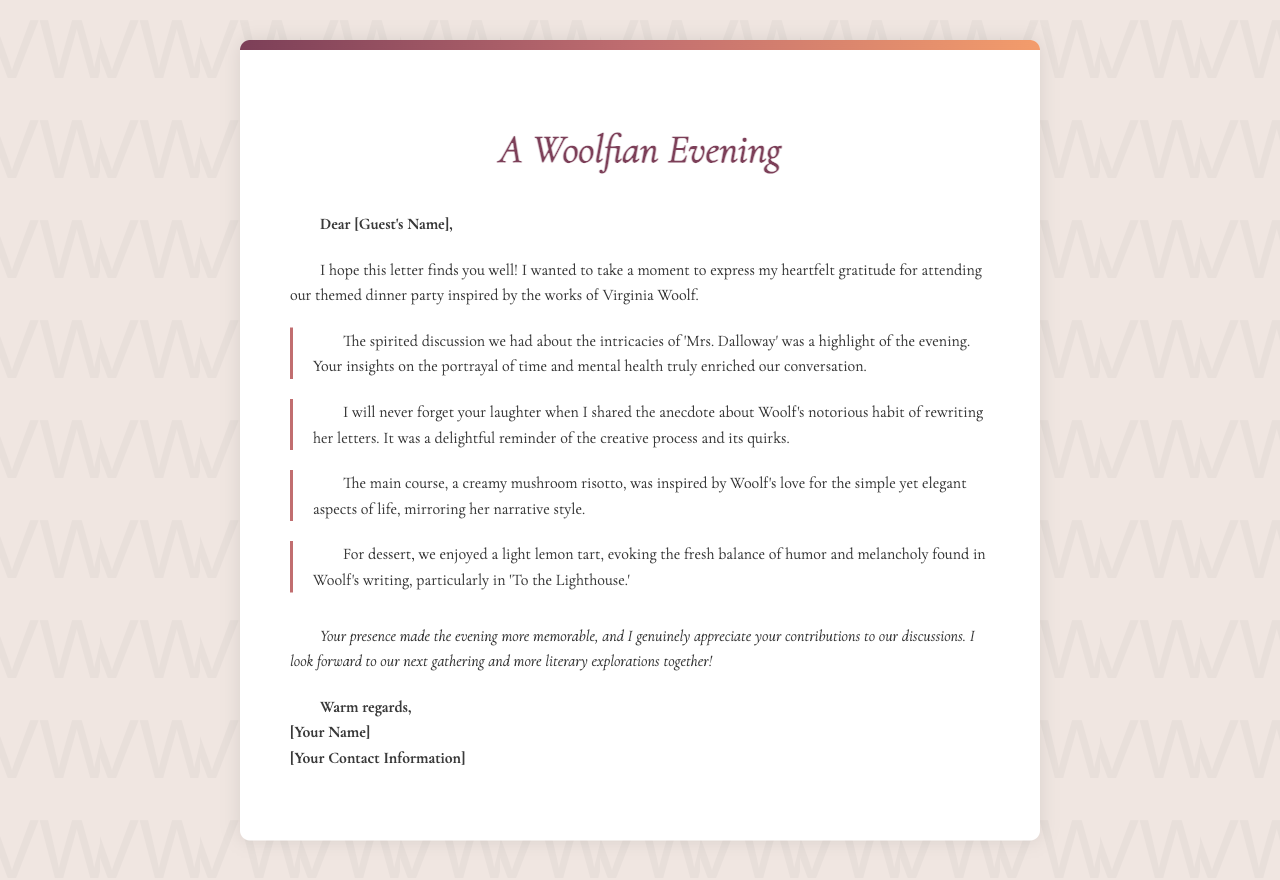What is the theme of the dinner party? The theme of the dinner party is inspired by the works of Virginia Woolf, as indicated in the title.
Answer: Virginia Woolf What was the main dish served? The main dish mentioned in the letter is inspired by Woolf's love for simple and elegant aspects of life.
Answer: Creamy mushroom risotto Who was the guest of honor? The letter does not specify a guest of honor, but addresses a specific guest by a placeholder name.
Answer: [Guest's Name] What notable work of Woolf was discussed? The letter mentions a specific work by Virginia Woolf that was discussed during the dinner party.
Answer: Mrs. Dalloway What dessert was served at the dinner party? The dessert mentioned in the letter reflects a balance of humor and melancholy found in Woolf's writing.
Answer: Light lemon tart What notable event occurred during the evening? A memorable highlight of the evening involved a discussion about 'Mrs. Dalloway.'
Answer: Spirited discussion What did the host appreciate most about the guest? The host appreciated the contributions of the guest to the discussions.
Answer: Your contributions What unique habit of Woolf was mentioned? The letter refers to a specific habit of Virginia Woolf that adds a creative touch to her character.
Answer: Notorious habit of rewriting her letters 